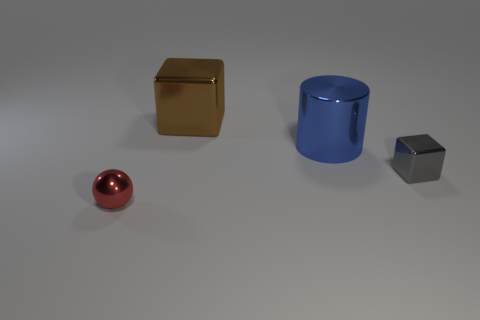The tiny object to the left of the tiny metallic thing that is to the right of the tiny metallic object left of the small gray object is made of what material?
Offer a very short reply. Metal. Does the small block have the same color as the tiny metallic sphere?
Offer a terse response. No. Are there any rubber objects of the same color as the small metal block?
Keep it short and to the point. No. There is a object that is the same size as the cylinder; what is its shape?
Offer a very short reply. Cube. Is the number of small yellow balls less than the number of large cylinders?
Make the answer very short. Yes. What number of cyan rubber cubes are the same size as the cylinder?
Give a very brief answer. 0. What is the material of the brown cube?
Provide a succinct answer. Metal. There is a block to the right of the big brown shiny thing; how big is it?
Provide a succinct answer. Small. What number of cyan metal things are the same shape as the big brown object?
Make the answer very short. 0. There is a blue object that is made of the same material as the red sphere; what shape is it?
Your answer should be very brief. Cylinder. 